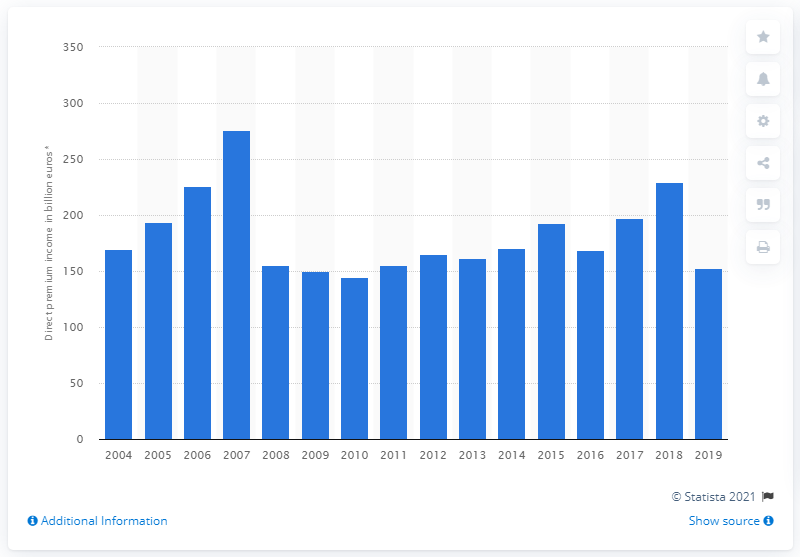Give some essential details in this illustration. In the year 2019, the premium for life insurance was 152.67. The highest amount of life insurance premiums in the UK in 2007 was 275.52. In 2008, the value of life insurance premiums was 155.41. 